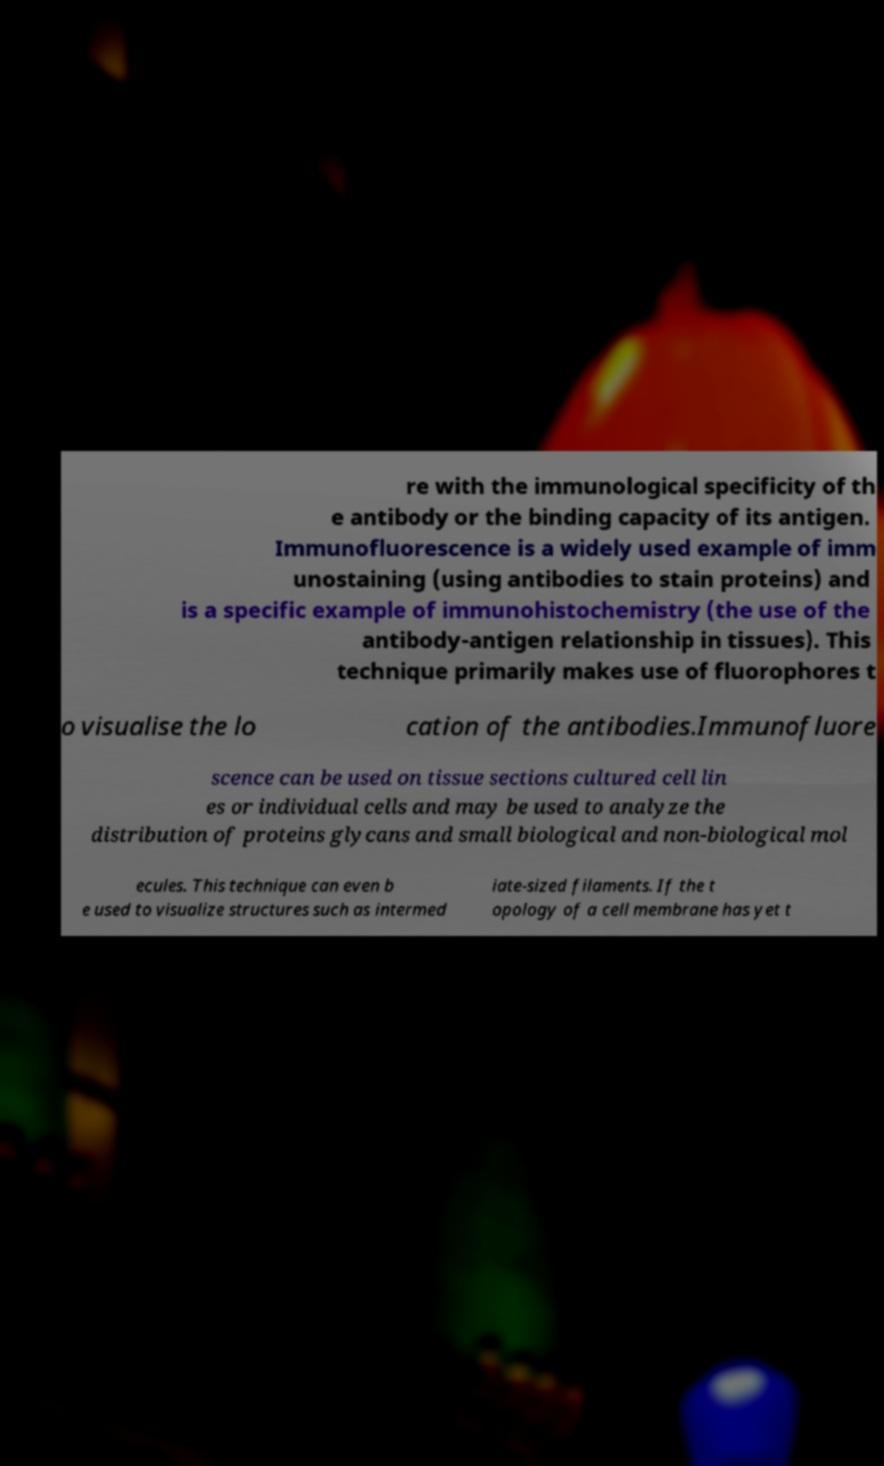Can you accurately transcribe the text from the provided image for me? re with the immunological specificity of th e antibody or the binding capacity of its antigen. Immunofluorescence is a widely used example of imm unostaining (using antibodies to stain proteins) and is a specific example of immunohistochemistry (the use of the antibody-antigen relationship in tissues). This technique primarily makes use of fluorophores t o visualise the lo cation of the antibodies.Immunofluore scence can be used on tissue sections cultured cell lin es or individual cells and may be used to analyze the distribution of proteins glycans and small biological and non-biological mol ecules. This technique can even b e used to visualize structures such as intermed iate-sized filaments. If the t opology of a cell membrane has yet t 